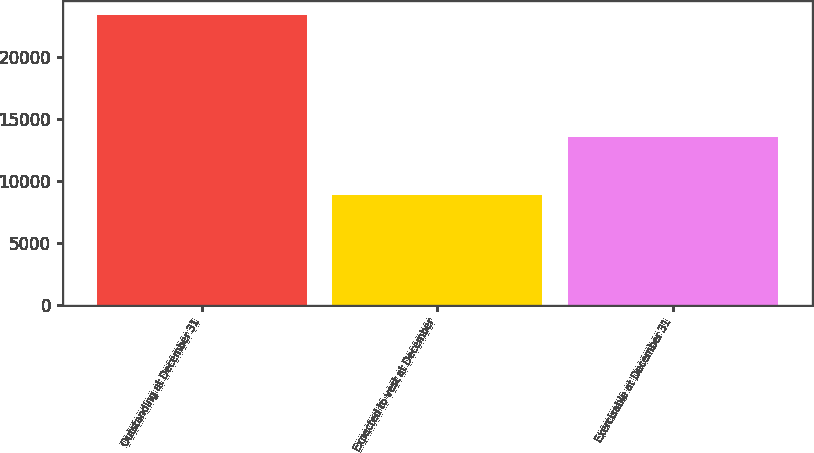Convert chart. <chart><loc_0><loc_0><loc_500><loc_500><bar_chart><fcel>Outstanding at December 31<fcel>Expected to vest at December<fcel>Exercisable at December 31<nl><fcel>23300<fcel>8893<fcel>13536<nl></chart> 